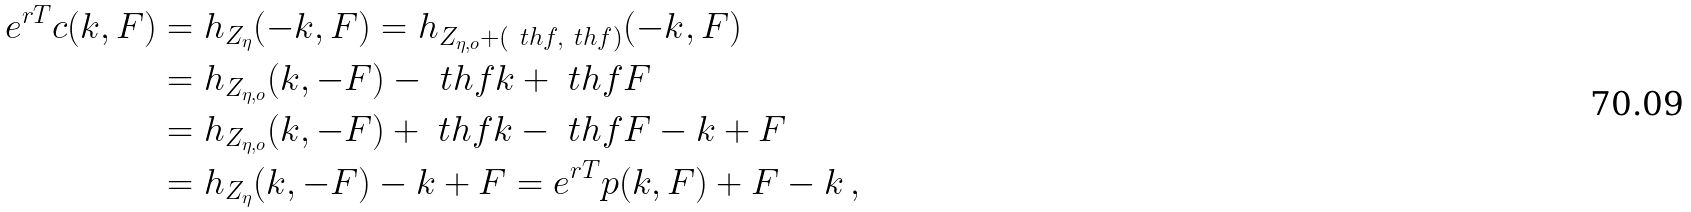Convert formula to latex. <formula><loc_0><loc_0><loc_500><loc_500>e ^ { r T } c ( k , F ) & = h _ { Z _ { \eta } } ( - k , F ) = h _ { Z _ { \eta , o } + ( \ t h f , \ t h f ) } ( - k , F ) \\ & = h _ { Z _ { \eta , o } } ( k , - F ) - \ t h f k + \ t h f F \\ & = h _ { Z _ { \eta , o } } ( k , - F ) + \ t h f k - \ t h f F - k + F \\ & = h _ { Z _ { \eta } } ( k , - F ) - k + F = e ^ { r T } p ( k , F ) + F - k \, ,</formula> 